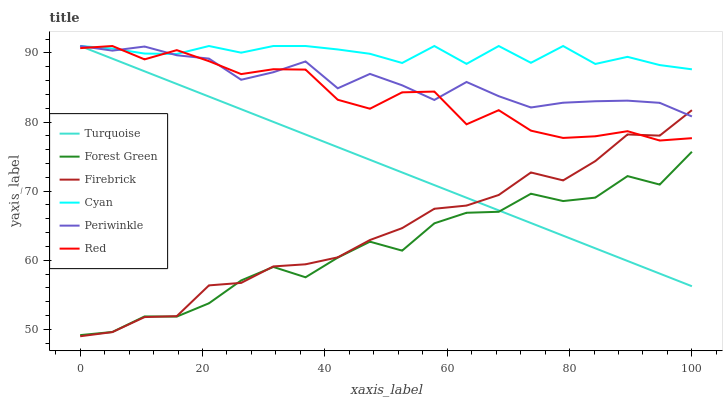Does Forest Green have the minimum area under the curve?
Answer yes or no. Yes. Does Cyan have the maximum area under the curve?
Answer yes or no. Yes. Does Firebrick have the minimum area under the curve?
Answer yes or no. No. Does Firebrick have the maximum area under the curve?
Answer yes or no. No. Is Turquoise the smoothest?
Answer yes or no. Yes. Is Forest Green the roughest?
Answer yes or no. Yes. Is Firebrick the smoothest?
Answer yes or no. No. Is Firebrick the roughest?
Answer yes or no. No. Does Firebrick have the lowest value?
Answer yes or no. Yes. Does Forest Green have the lowest value?
Answer yes or no. No. Does Red have the highest value?
Answer yes or no. Yes. Does Firebrick have the highest value?
Answer yes or no. No. Is Forest Green less than Red?
Answer yes or no. Yes. Is Cyan greater than Firebrick?
Answer yes or no. Yes. Does Red intersect Turquoise?
Answer yes or no. Yes. Is Red less than Turquoise?
Answer yes or no. No. Is Red greater than Turquoise?
Answer yes or no. No. Does Forest Green intersect Red?
Answer yes or no. No. 